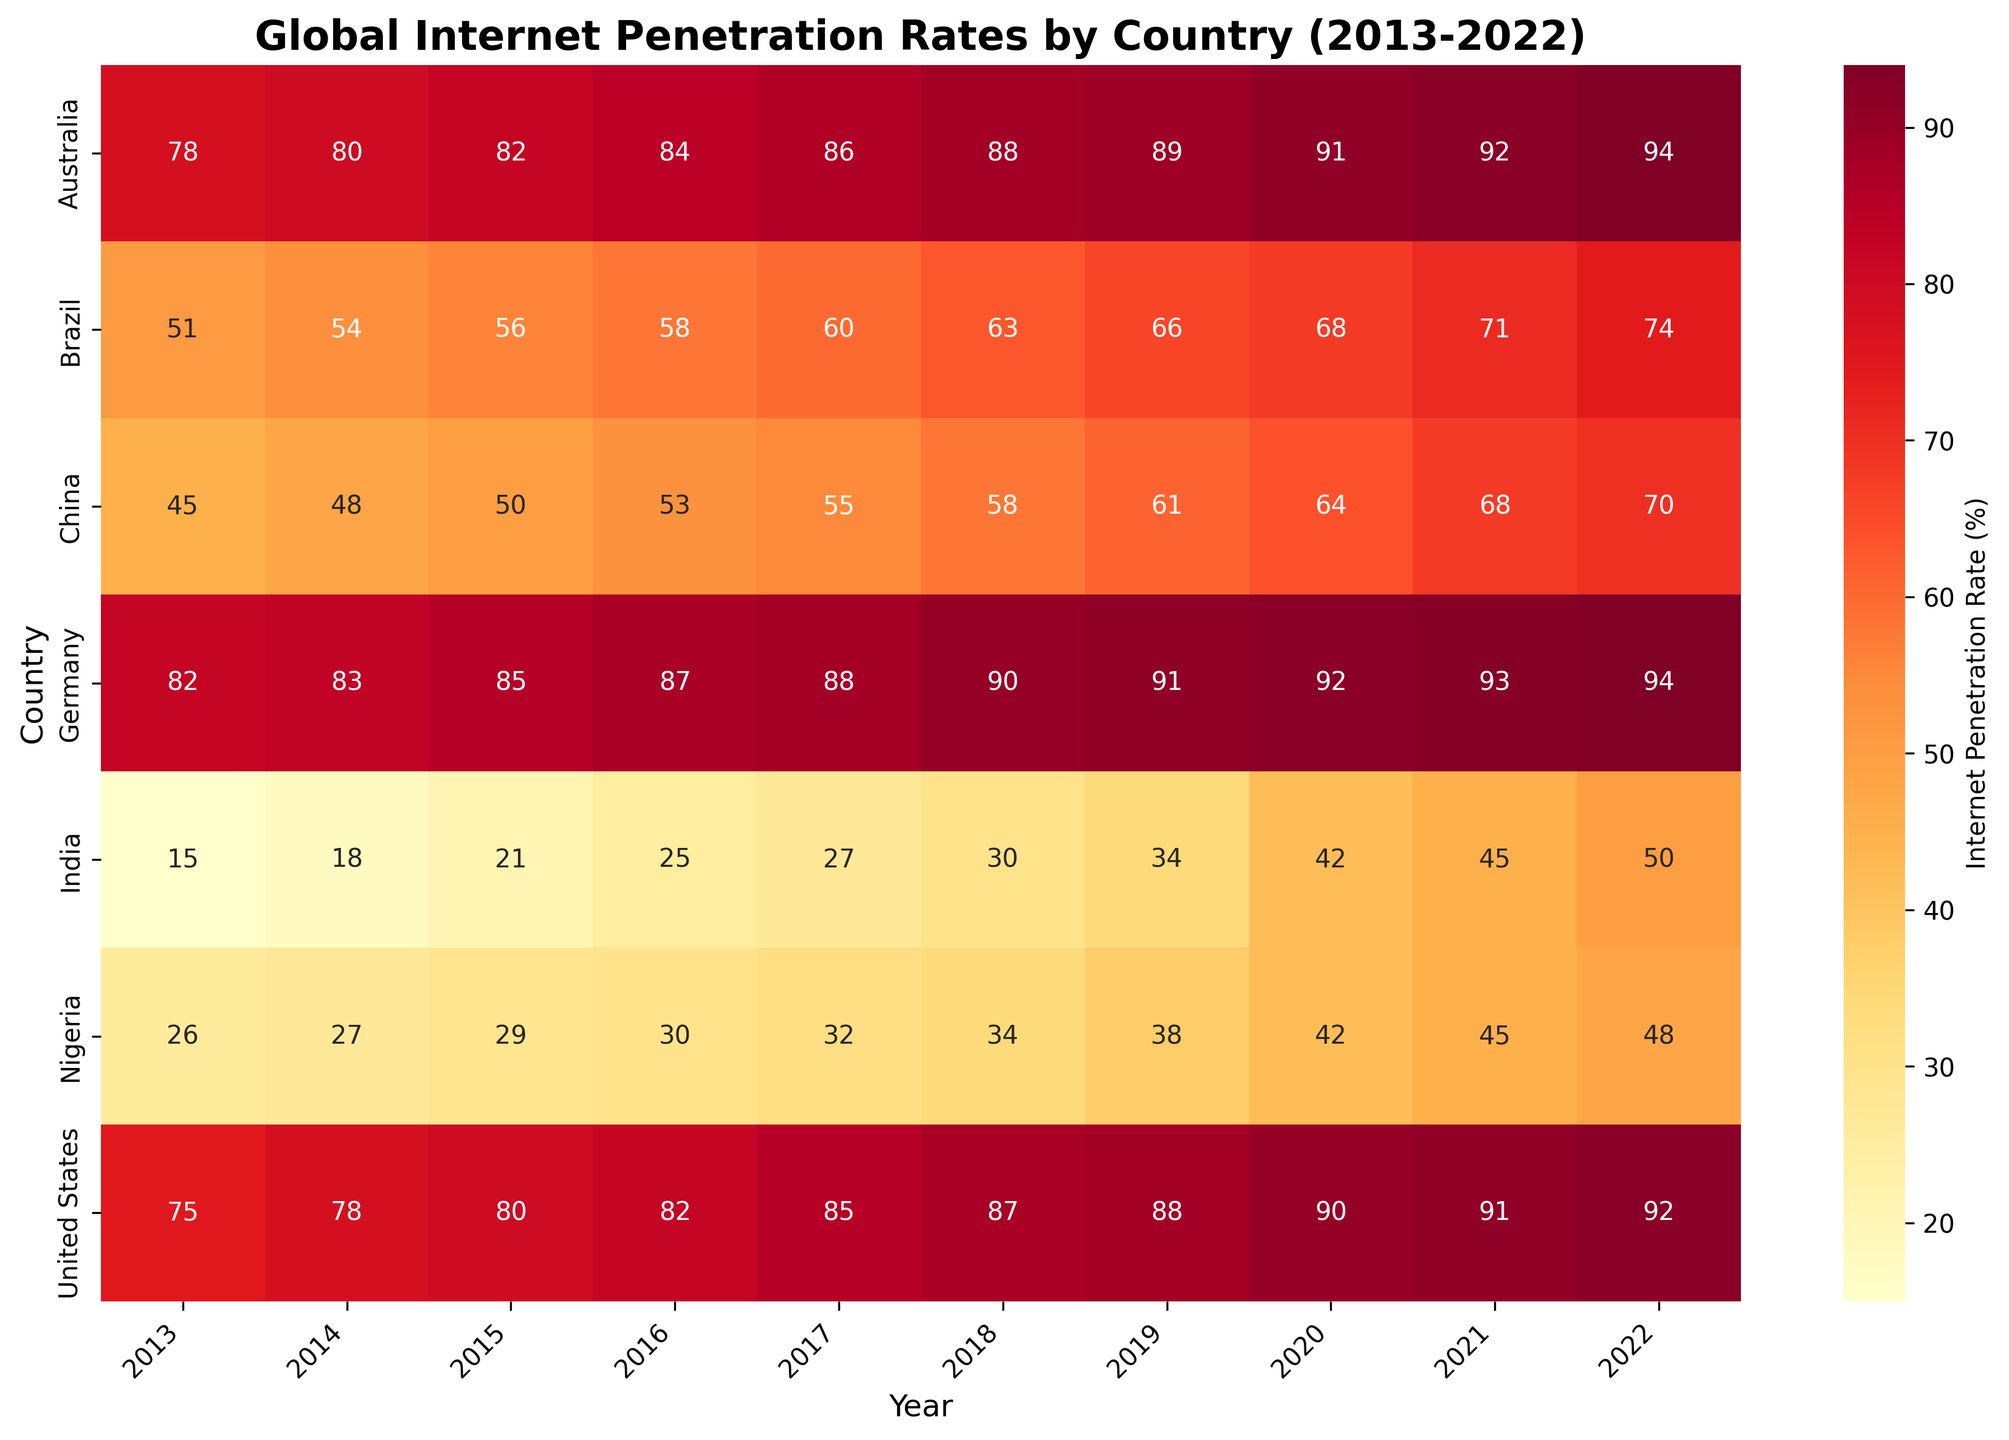What is the title of the heatmap? The title is usually displayed at the top of the figure in a larger and bold font. It provides a brief description of what the heatmap represents.
Answer: Global Internet Penetration Rates by Country (2013-2022) Which country had the highest internet penetration rate in 2022? To find the highest internet penetration rate in 2022, locate the column for 2022 and identify the country with the highest value.
Answer: Germany and Australia How has the internet penetration rate in India changed from 2013 to 2022? Look at the row corresponding to India and observe the trend in the values from 2013 to 2022 to describe the change over time.
Answer: Increased from 15% to 50% Which country shows the largest increase in internet penetration rate between 2013 and 2022? To determine the largest increase, calculate the difference between the 2013 and 2022 values for each country and compare the results to identify the largest difference.
Answer: India What was the internet penetration rate in Brazil in 2015? Locate the row for Brazil and find the value in the column for the year 2015.
Answer: 56% How does the internet penetration rate in China in 2022 compare to that in 2013? Compare the values in the row for China under the columns for 2013 and 2022 to determine the change.
Answer: Increased from 45% to 70% Which country had a higher internet penetration rate in 2015 – Nigeria or Brazil? Compare the values in the 2015 column for the rows corresponding to Nigeria and Brazil.
Answer: Brazil What is the average internet penetration rate in Germany from 2013 to 2022? Add up the values for Germany from 2013 to 2022, and then divide by the number of years, which is 10.  (82+83+85+87+88+90+91+92+93+94)/10 = 88.5
Answer: 88.5% Which country had the lowest internet penetration rate in 2020? Locate the column for 2020 and find the country with the lowest value in that column.
Answer: India In which year did the internet penetration rate in the United States reach 90%? Locate the row for the United States and find the column where the value is 90%.
Answer: 2020 